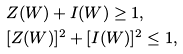<formula> <loc_0><loc_0><loc_500><loc_500>& Z ( W ) + I ( W ) \geq 1 , \\ & [ Z ( W ) ] ^ { 2 } + [ I ( W ) ] ^ { 2 } \leq 1 ,</formula> 